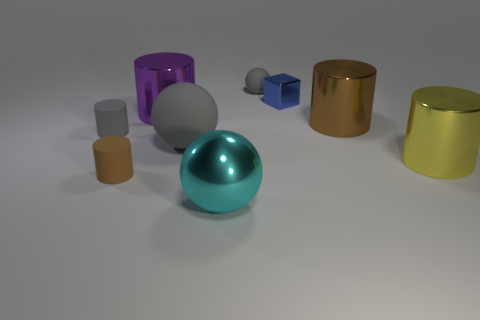Which of these objects appears to have the most reflective surface? The object with the most reflective surface appears to be the large teal sphere in the center. Its surface is so glossy that it almost mirrors its surroundings. Could you describe the lighting in the scene? The lighting in the scene seems to be diffused, likely from an overhead source. There are subtle shadows cast under each object, indicating the light is coming from above and slightly to the right, providing a soft illumination to the entire arrangement. 